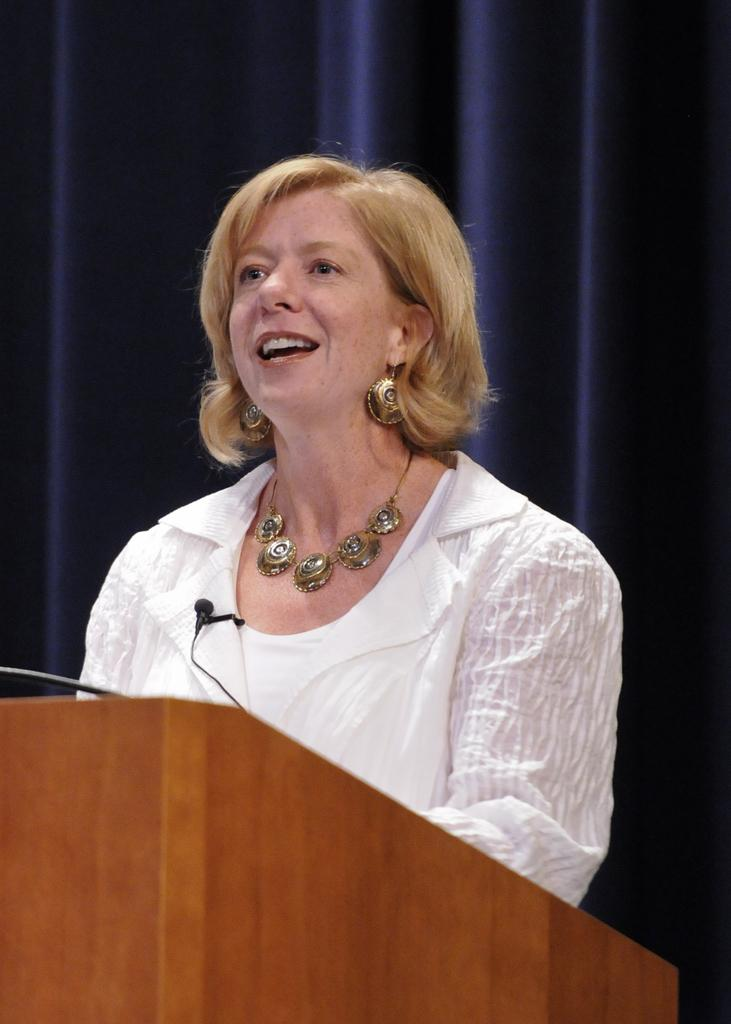What is the woman in the image doing? The woman is standing in the image and smiling. What might the woman be using the microphone for? The microphone on the podium in the foreground suggests that the woman might be giving a speech or presentation. What can be seen in the background of the image? There is a curtain in the background of the image. What type of sugar is being used to sweeten the summer air in the image? There is no mention of sugar or summer in the image, and therefore no such activity can be observed. 